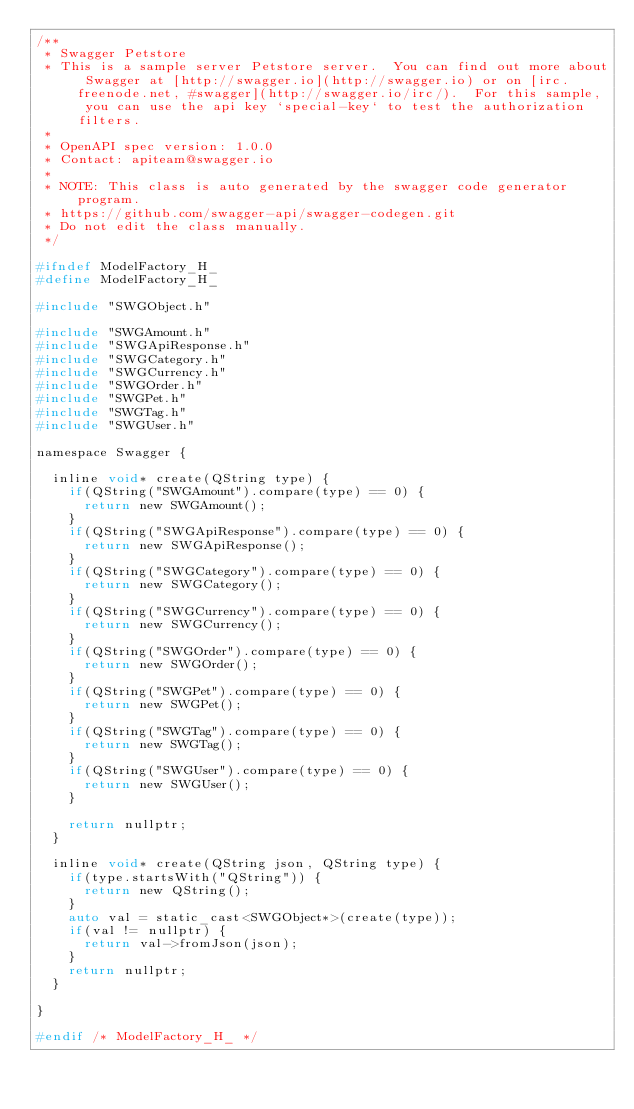<code> <loc_0><loc_0><loc_500><loc_500><_C_>/**
 * Swagger Petstore
 * This is a sample server Petstore server.  You can find out more about Swagger at [http://swagger.io](http://swagger.io) or on [irc.freenode.net, #swagger](http://swagger.io/irc/).  For this sample, you can use the api key `special-key` to test the authorization filters.
 *
 * OpenAPI spec version: 1.0.0
 * Contact: apiteam@swagger.io
 *
 * NOTE: This class is auto generated by the swagger code generator program.
 * https://github.com/swagger-api/swagger-codegen.git
 * Do not edit the class manually.
 */

#ifndef ModelFactory_H_
#define ModelFactory_H_

#include "SWGObject.h"

#include "SWGAmount.h"
#include "SWGApiResponse.h"
#include "SWGCategory.h"
#include "SWGCurrency.h"
#include "SWGOrder.h"
#include "SWGPet.h"
#include "SWGTag.h"
#include "SWGUser.h"

namespace Swagger {

  inline void* create(QString type) {
    if(QString("SWGAmount").compare(type) == 0) {
      return new SWGAmount();
    }
    if(QString("SWGApiResponse").compare(type) == 0) {
      return new SWGApiResponse();
    }
    if(QString("SWGCategory").compare(type) == 0) {
      return new SWGCategory();
    }
    if(QString("SWGCurrency").compare(type) == 0) {
      return new SWGCurrency();
    }
    if(QString("SWGOrder").compare(type) == 0) {
      return new SWGOrder();
    }
    if(QString("SWGPet").compare(type) == 0) {
      return new SWGPet();
    }
    if(QString("SWGTag").compare(type) == 0) {
      return new SWGTag();
    }
    if(QString("SWGUser").compare(type) == 0) {
      return new SWGUser();
    }
    
    return nullptr;
  }

  inline void* create(QString json, QString type) {
    if(type.startsWith("QString")) {
      return new QString();
    }    
    auto val = static_cast<SWGObject*>(create(type));
    if(val != nullptr) {
      return val->fromJson(json);
    }
    return nullptr;
  }

}

#endif /* ModelFactory_H_ */
</code> 